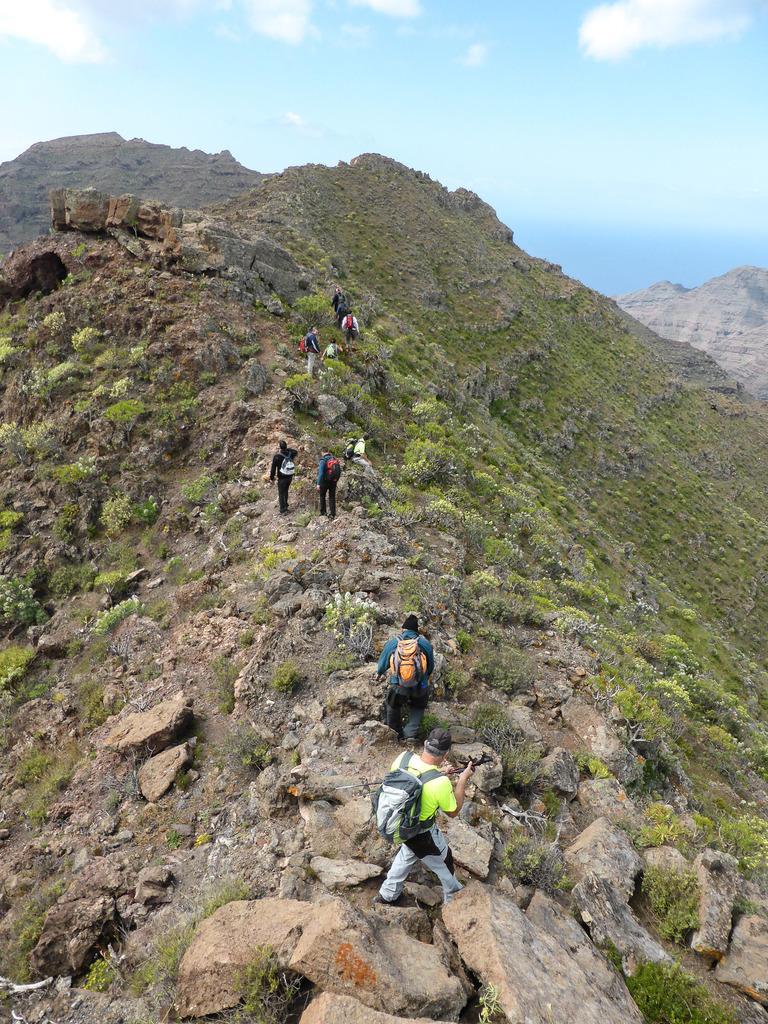Could you give a brief overview of what you see in this image? In this image I can see some people are walking on the hill. In the background, I can see the clouds in the sky. 